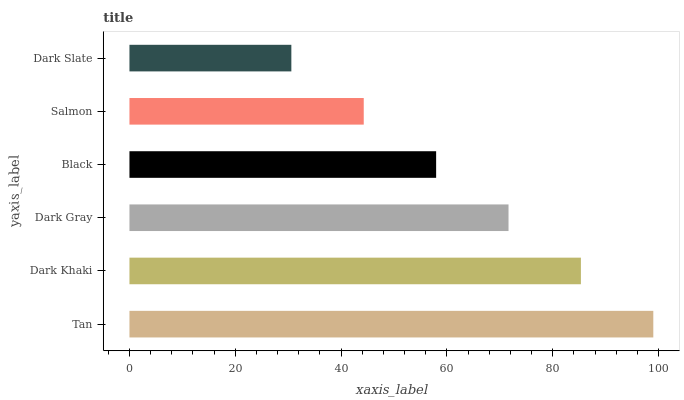Is Dark Slate the minimum?
Answer yes or no. Yes. Is Tan the maximum?
Answer yes or no. Yes. Is Dark Khaki the minimum?
Answer yes or no. No. Is Dark Khaki the maximum?
Answer yes or no. No. Is Tan greater than Dark Khaki?
Answer yes or no. Yes. Is Dark Khaki less than Tan?
Answer yes or no. Yes. Is Dark Khaki greater than Tan?
Answer yes or no. No. Is Tan less than Dark Khaki?
Answer yes or no. No. Is Dark Gray the high median?
Answer yes or no. Yes. Is Black the low median?
Answer yes or no. Yes. Is Dark Slate the high median?
Answer yes or no. No. Is Dark Khaki the low median?
Answer yes or no. No. 